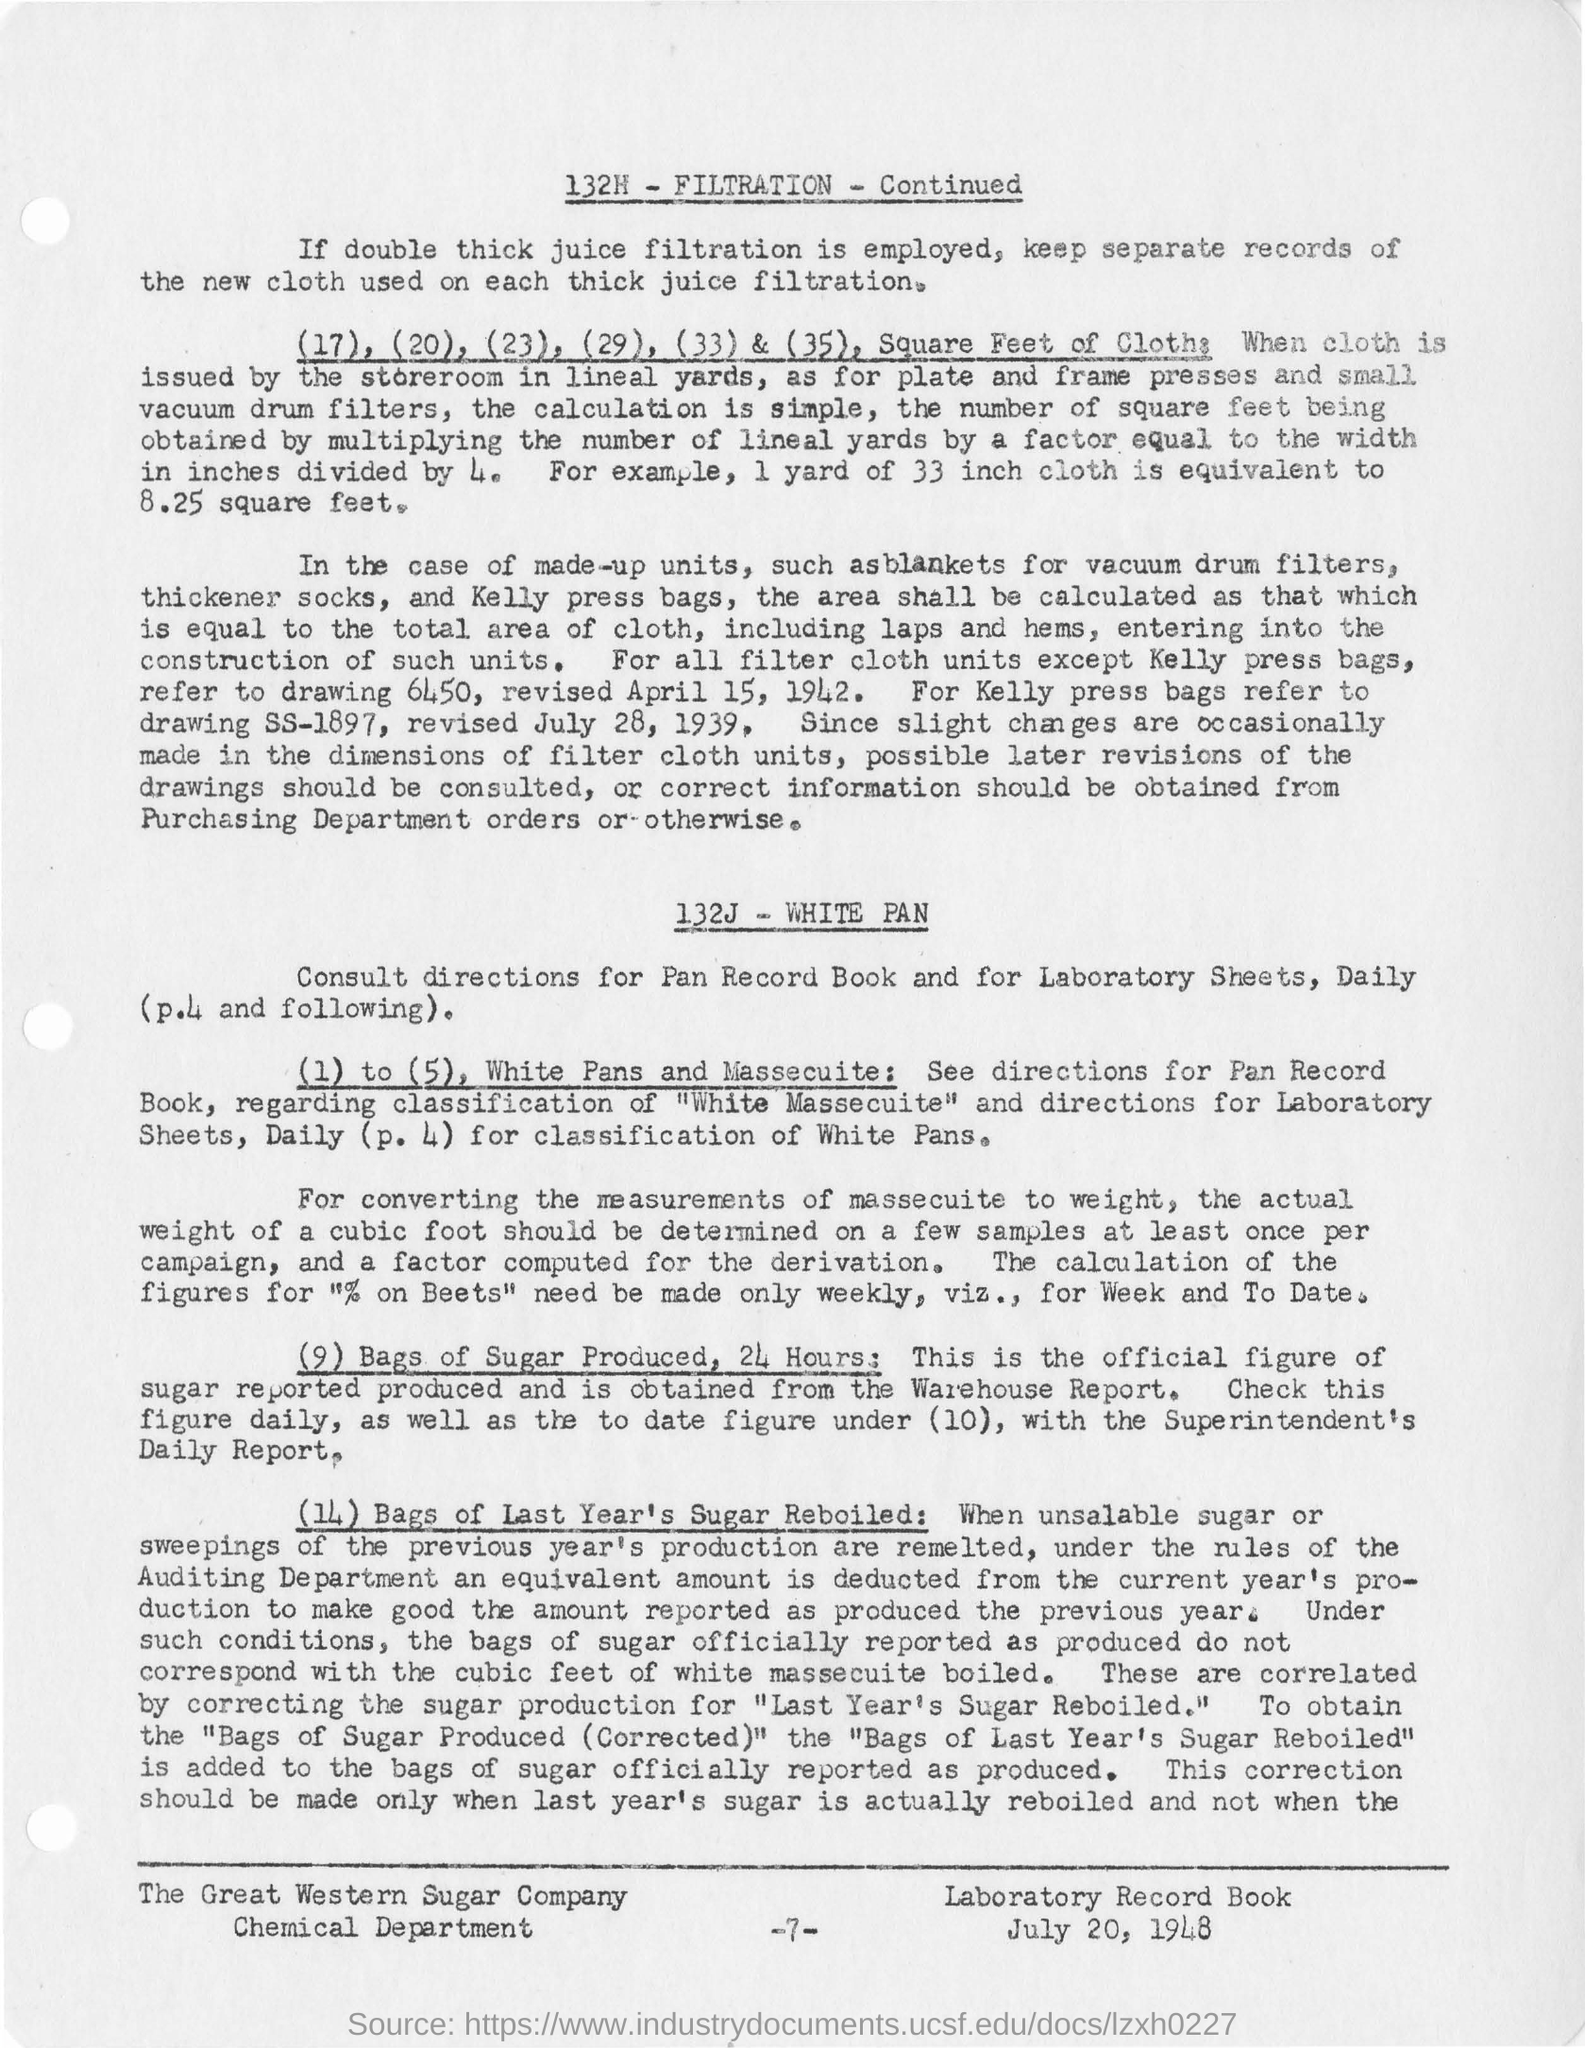Name the press bag which was not refer to drawing 6450?
Provide a short and direct response. Kelly press bags. 1 yard of 33 inch cloth is equivalent to ?
Offer a terse response. 8.25 square feet. How frequently does cubic foot of sample to be determined?
Make the answer very short. At least once per campaign. Offcial figure of sugar produced in 24 hrs can be  obtained from ?
Your answer should be compact. Warehouse Report. What is the page no mentioned in this document?
Your answer should be very brief. -7-. 